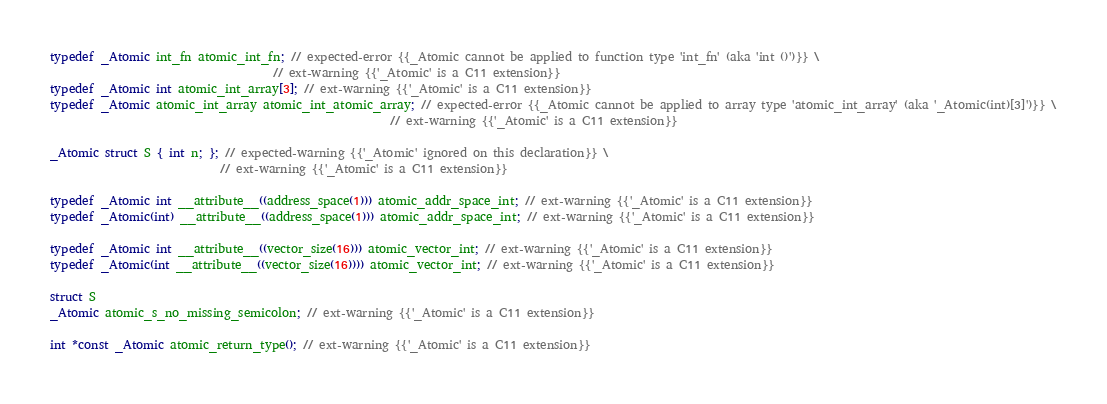Convert code to text. <code><loc_0><loc_0><loc_500><loc_500><_C_>typedef _Atomic int_fn atomic_int_fn; // expected-error {{_Atomic cannot be applied to function type 'int_fn' (aka 'int ()')}} \
                                      // ext-warning {{'_Atomic' is a C11 extension}}
typedef _Atomic int atomic_int_array[3]; // ext-warning {{'_Atomic' is a C11 extension}}
typedef _Atomic atomic_int_array atomic_int_atomic_array; // expected-error {{_Atomic cannot be applied to array type 'atomic_int_array' (aka '_Atomic(int)[3]')}} \
                                                          // ext-warning {{'_Atomic' is a C11 extension}}

_Atomic struct S { int n; }; // expected-warning {{'_Atomic' ignored on this declaration}} \
                             // ext-warning {{'_Atomic' is a C11 extension}}

typedef _Atomic int __attribute__((address_space(1))) atomic_addr_space_int; // ext-warning {{'_Atomic' is a C11 extension}}
typedef _Atomic(int) __attribute__((address_space(1))) atomic_addr_space_int; // ext-warning {{'_Atomic' is a C11 extension}}

typedef _Atomic int __attribute__((vector_size(16))) atomic_vector_int; // ext-warning {{'_Atomic' is a C11 extension}}
typedef _Atomic(int __attribute__((vector_size(16)))) atomic_vector_int; // ext-warning {{'_Atomic' is a C11 extension}}

struct S
_Atomic atomic_s_no_missing_semicolon; // ext-warning {{'_Atomic' is a C11 extension}}

int *const _Atomic atomic_return_type(); // ext-warning {{'_Atomic' is a C11 extension}}
</code> 